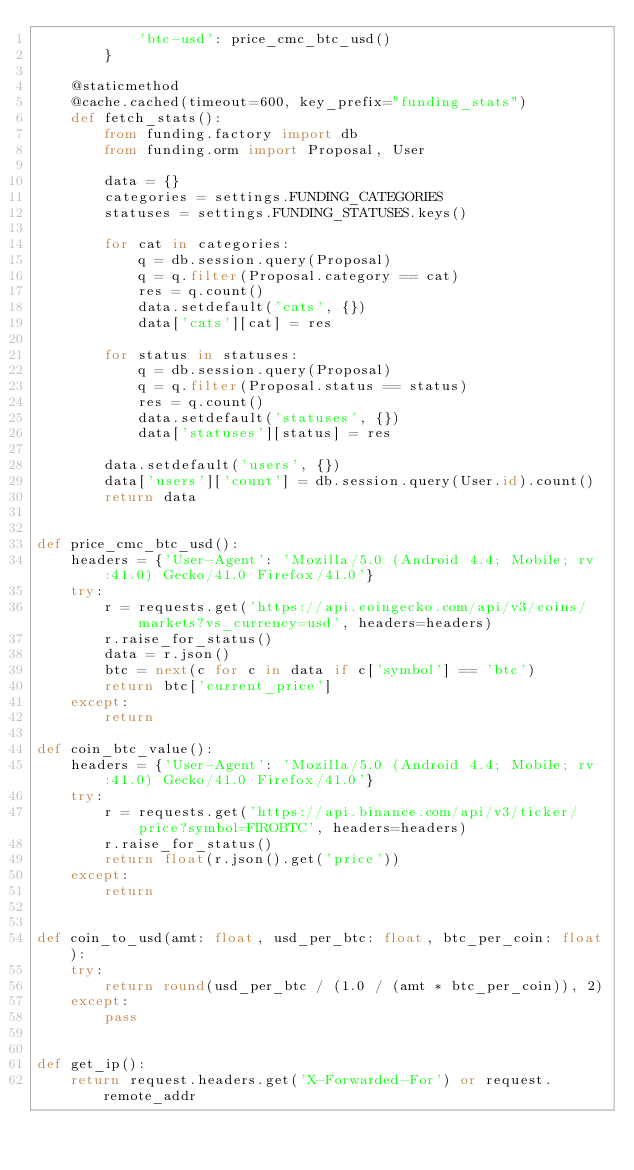Convert code to text. <code><loc_0><loc_0><loc_500><loc_500><_Python_>            'btc-usd': price_cmc_btc_usd()
        }

    @staticmethod
    @cache.cached(timeout=600, key_prefix="funding_stats")
    def fetch_stats():
        from funding.factory import db
        from funding.orm import Proposal, User

        data = {}
        categories = settings.FUNDING_CATEGORIES
        statuses = settings.FUNDING_STATUSES.keys()

        for cat in categories:
            q = db.session.query(Proposal)
            q = q.filter(Proposal.category == cat)
            res = q.count()
            data.setdefault('cats', {})
            data['cats'][cat] = res

        for status in statuses:
            q = db.session.query(Proposal)
            q = q.filter(Proposal.status == status)
            res = q.count()
            data.setdefault('statuses', {})
            data['statuses'][status] = res

        data.setdefault('users', {})
        data['users']['count'] = db.session.query(User.id).count()
        return data


def price_cmc_btc_usd():
    headers = {'User-Agent': 'Mozilla/5.0 (Android 4.4; Mobile; rv:41.0) Gecko/41.0 Firefox/41.0'}
    try:
        r = requests.get('https://api.coingecko.com/api/v3/coins/markets?vs_currency=usd', headers=headers)
        r.raise_for_status()
        data = r.json()
        btc = next(c for c in data if c['symbol'] == 'btc')
        return btc['current_price']
    except:
        return

def coin_btc_value():
    headers = {'User-Agent': 'Mozilla/5.0 (Android 4.4; Mobile; rv:41.0) Gecko/41.0 Firefox/41.0'}
    try:
        r = requests.get('https://api.binance.com/api/v3/ticker/price?symbol=FIROBTC', headers=headers)
        r.raise_for_status()
        return float(r.json().get('price'))
    except:
        return


def coin_to_usd(amt: float, usd_per_btc: float, btc_per_coin: float):
    try:
        return round(usd_per_btc / (1.0 / (amt * btc_per_coin)), 2)
    except:
        pass


def get_ip():
    return request.headers.get('X-Forwarded-For') or request.remote_addr
</code> 